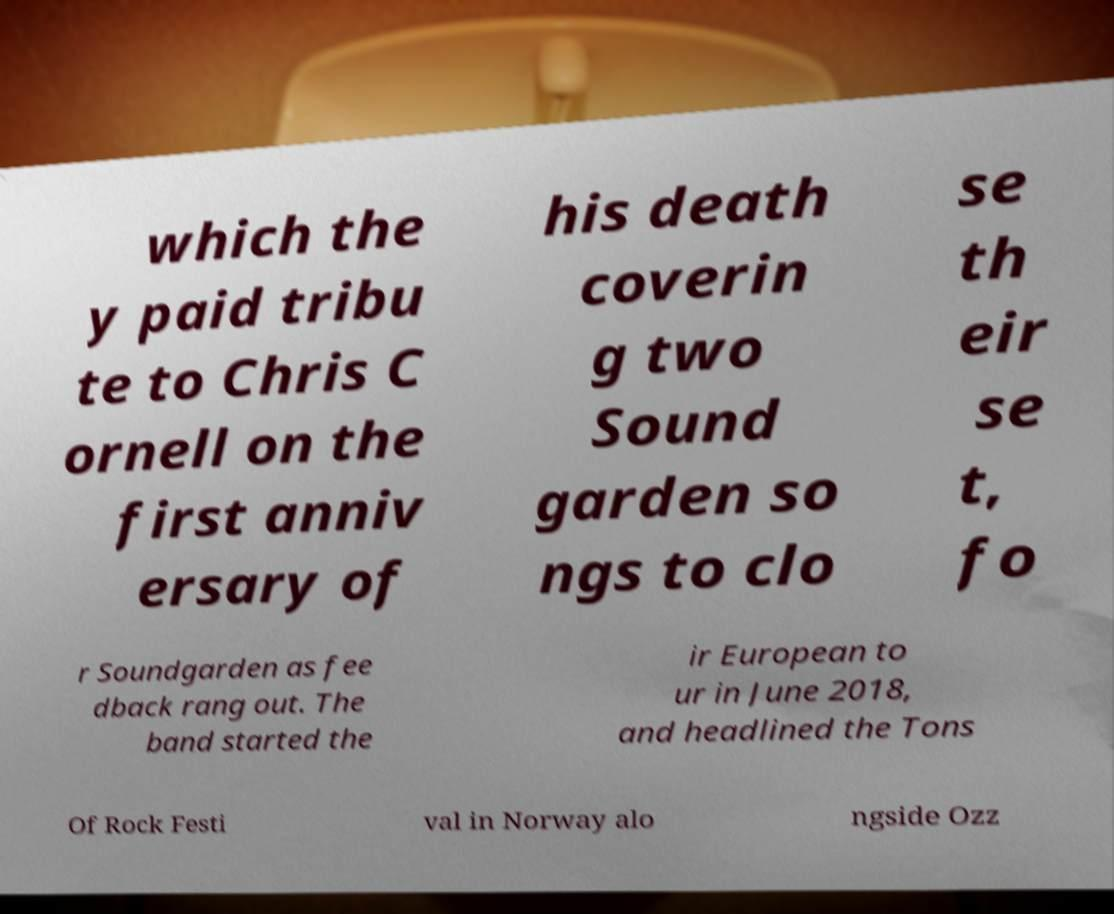Could you extract and type out the text from this image? which the y paid tribu te to Chris C ornell on the first anniv ersary of his death coverin g two Sound garden so ngs to clo se th eir se t, fo r Soundgarden as fee dback rang out. The band started the ir European to ur in June 2018, and headlined the Tons Of Rock Festi val in Norway alo ngside Ozz 